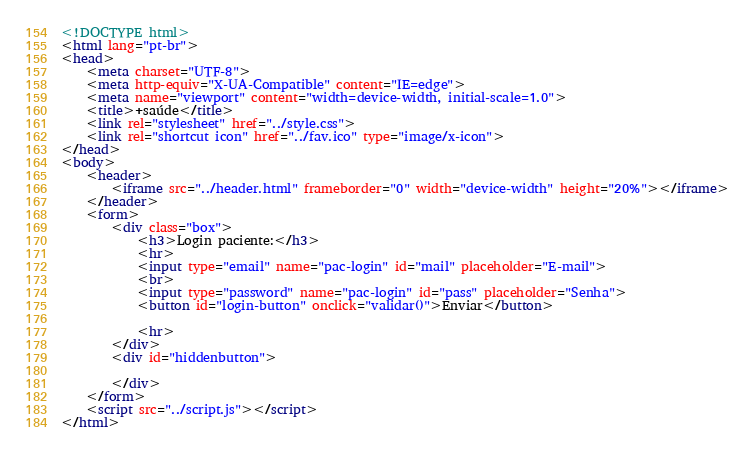Convert code to text. <code><loc_0><loc_0><loc_500><loc_500><_HTML_><!DOCTYPE html>
<html lang="pt-br">
<head>
    <meta charset="UTF-8">
    <meta http-equiv="X-UA-Compatible" content="IE=edge">
    <meta name="viewport" content="width=device-width, initial-scale=1.0">
    <title>+saúde</title>
    <link rel="stylesheet" href="../style.css">
    <link rel="shortcut icon" href="../fav.ico" type="image/x-icon">
</head>
<body>
    <header>
        <iframe src="../header.html" frameborder="0" width="device-width" height="20%"></iframe>
    </header>
    <form>
        <div class="box">
            <h3>Login paciente:</h3>
            <hr>    
            <input type="email" name="pac-login" id="mail" placeholder="E-mail">
            <br>
            <input type="password" name="pac-login" id="pass" placeholder="Senha">
            <button id="login-button" onclick="validar()">Enviar</button>
            
            <hr>
        </div>
        <div id="hiddenbutton">

        </div>
    </form>
    <script src="../script.js"></script>
</html></code> 